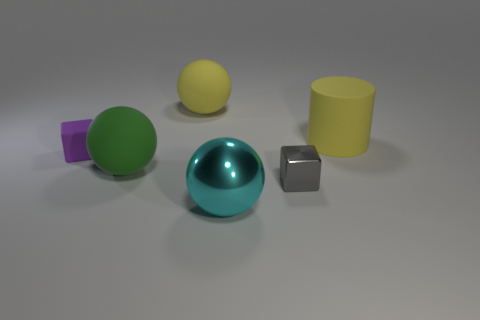How many tiny brown metal balls are there?
Offer a very short reply. 0. Are there any yellow things of the same size as the metallic sphere?
Give a very brief answer. Yes. Is the number of small things that are on the right side of the large green ball less than the number of big red rubber objects?
Give a very brief answer. No. Is the size of the gray metallic object the same as the yellow matte sphere?
Ensure brevity in your answer.  No. There is a green ball that is the same material as the big yellow cylinder; what is its size?
Keep it short and to the point. Large. What number of large things have the same color as the matte cylinder?
Your response must be concise. 1. Is the number of rubber things in front of the green rubber object less than the number of large yellow rubber things on the right side of the big cyan sphere?
Provide a succinct answer. Yes. There is a big yellow matte thing on the right side of the yellow sphere; does it have the same shape as the big green rubber thing?
Your answer should be very brief. No. Are the yellow thing that is left of the large yellow matte cylinder and the purple cube made of the same material?
Your response must be concise. Yes. The small thing to the right of the object behind the big thing that is right of the cyan shiny sphere is made of what material?
Keep it short and to the point. Metal. 